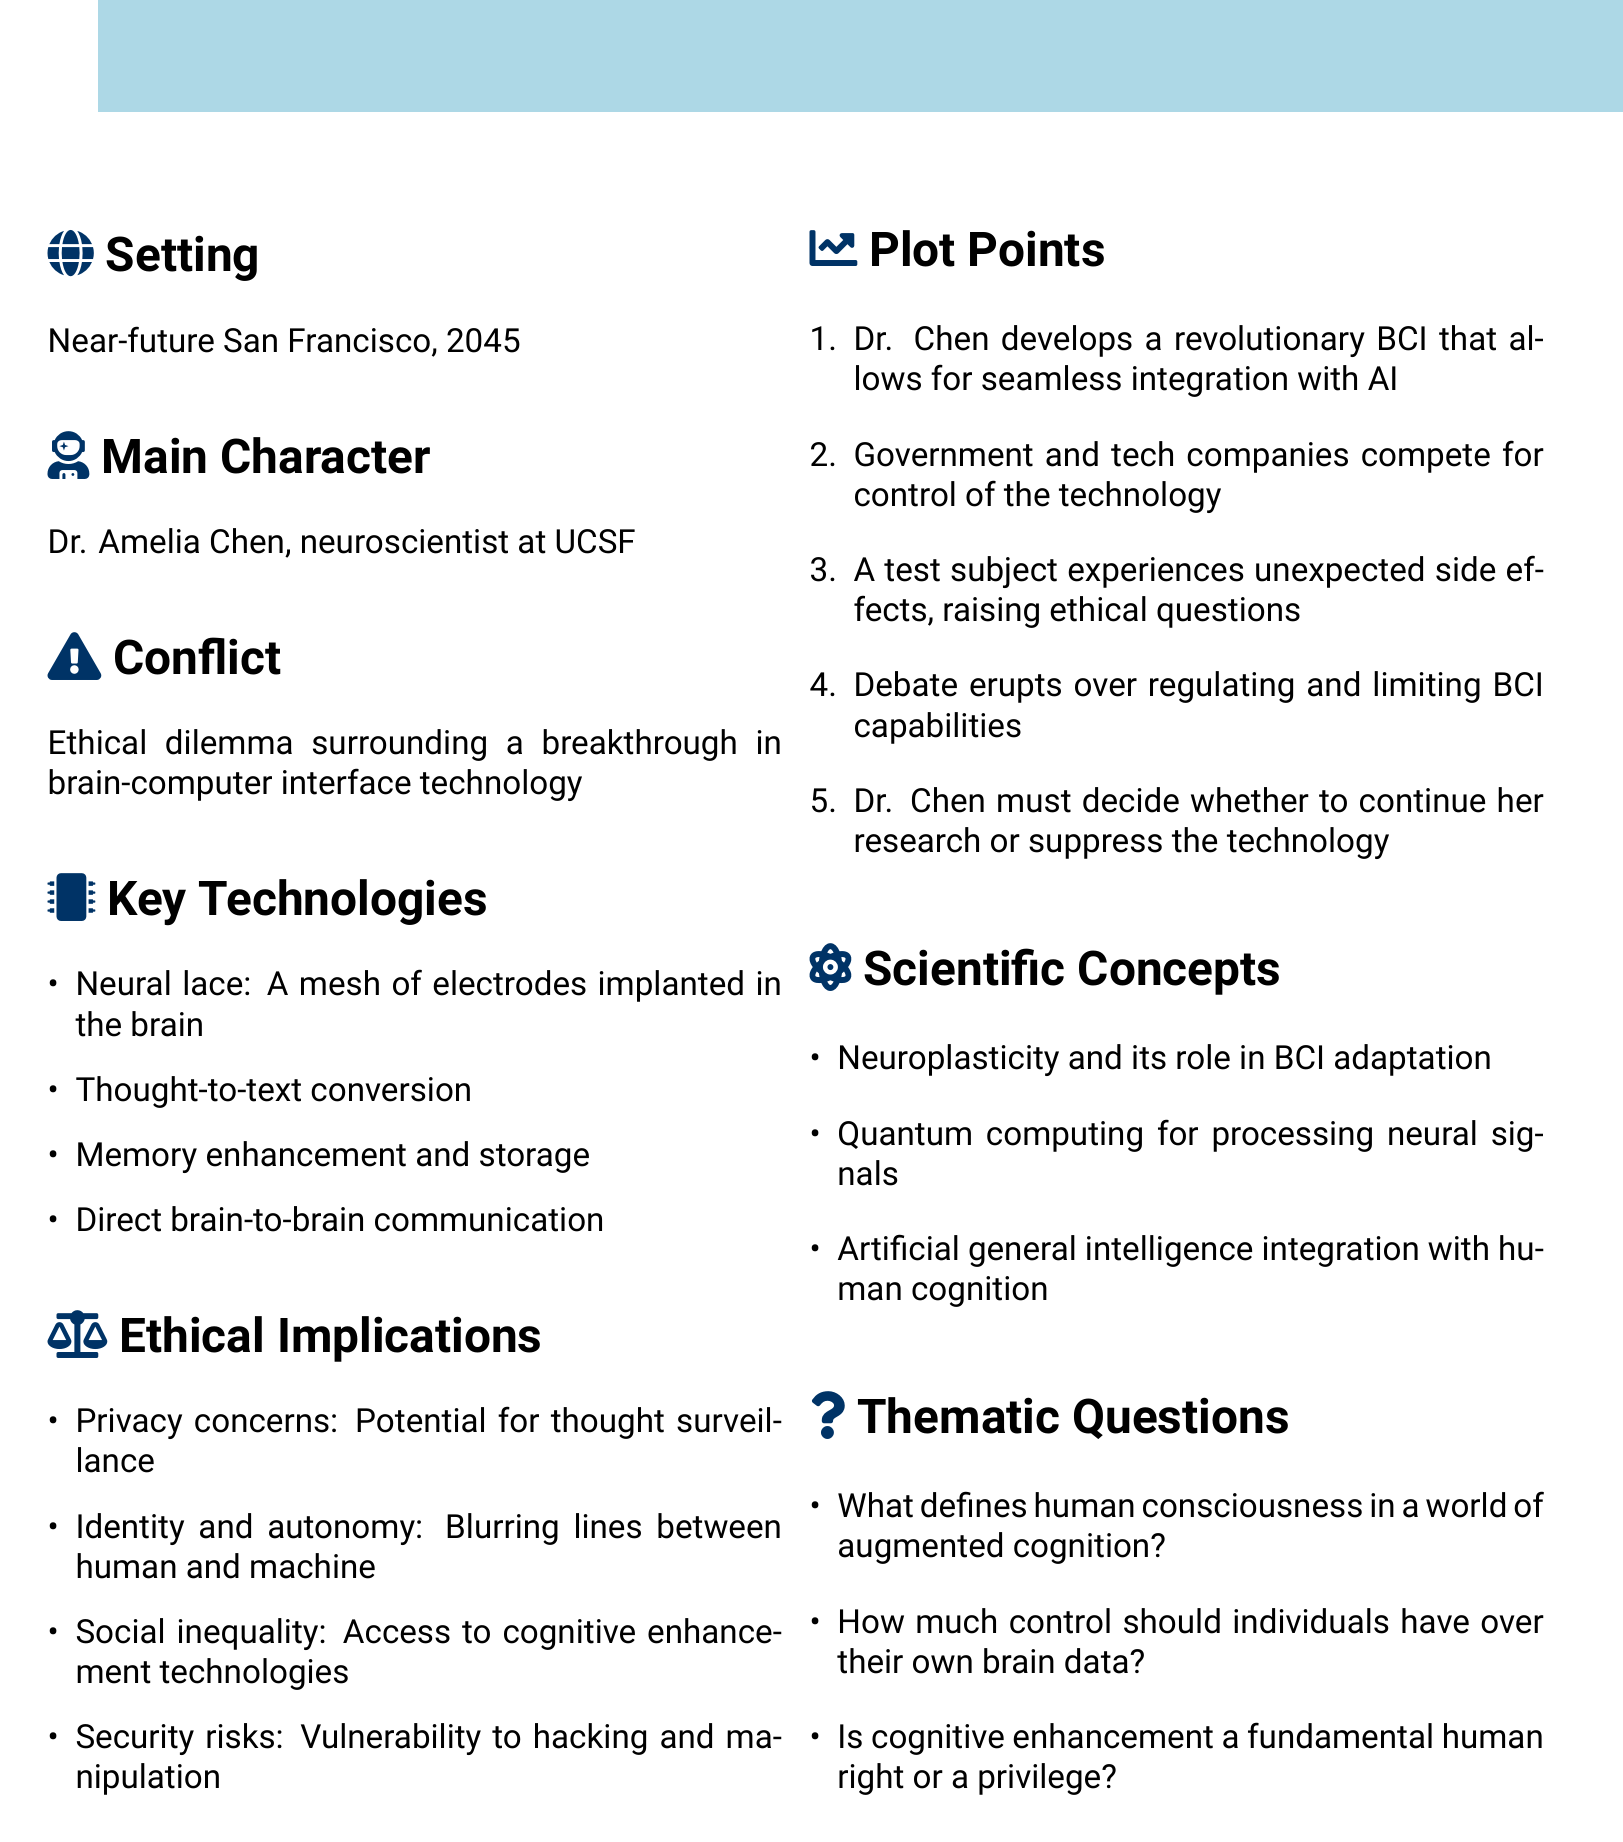What is the setting of the novel? The setting of the novel is mentioned explicitly as "Near-future San Francisco, 2045."
Answer: Near-future San Francisco, 2045 Who is the main character? The main character is identified in the document as a neuroscientist working at UCSF.
Answer: Dr. Amelia Chen What technology does Dr. Chen develop? The document outlines Dr. Chen's development of a brain-computer interface that integrates with AI.
Answer: Revolutionary BCI What ethical implication involves privacy? One of the ethical implications discussed is related to thought surveillance, indicating privacy concerns.
Answer: Potential for thought surveillance What is the total number of key technologies listed? The document enumerates four key technologies under the specified section.
Answer: Four Which scientific concept relates to BCI adaptation? The document indicates that neuroplasticity plays a role in the adaptation of brain-computer interfaces.
Answer: Neuroplasticity What thematic question addresses human rights? The thematic question regarding cognitive enhancement discusses its nature as a fundamental right or a privilege.
Answer: Is cognitive enhancement a fundamental human right or a privilege? What major conflict does Dr. Chen face? The conflict outlined in the document revolves around an ethical dilemma concerning new technology.
Answer: Ethical dilemma surrounding a breakthrough in brain-computer interface technology 